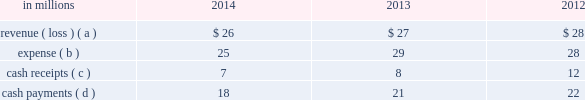The use of the two wholly-owned special purpose entities discussed below preserved the tax deferral that resulted from the 2007 temple-inland timberlands sales .
The company recognized an $ 840 million deferred tax liability in connection with the 2007 sales , which will be settled with the maturity of the notes in in october 2007 , temple-inland sold 1.55 million acres of timberlands for $ 2.38 billion .
The total consideration consisted almost entirely of notes due in 2027 issued by the buyer of the timberlands , which temple-inland contributed to two wholly-owned , bankruptcy-remote special purpose entities .
The notes are shown in financial assets of special purpose entities in the accompanying consolidated balance sheet and are supported by $ 2.38 billion of irrevocable letters of credit issued by three banks , which are required to maintain minimum credit ratings on their long-term debt .
In the third quarter of 2012 , international paper completed its preliminary analysis of the acquisition date fair value of the notes and determined it to be $ 2.09 billion .
As of december 31 , 2014 and 2013 , the fair value of the notes was $ 2.27 billion and $ 2.62 billion , respectively .
These notes are classified as level 2 within the fair value hierarchy , which is further defined in note 14 .
In december 2007 , temple-inland's two wholly-owned special purpose entities borrowed $ 2.14 billion shown in nonrecourse financial liabilities of special purpose entities in the accompanying consolidated balance sheet .
The loans are repayable in 2027 and are secured only by the $ 2.38 billion of notes and the irrevocable letters of credit securing the notes and are nonrecourse to the company .
The loan agreements provide that if a credit rating of any of the banks issuing the letters of credit is downgraded below the specified threshold , the letters of credit issued by that bank must be replaced within 30 days with letters of credit from another qualifying financial institution .
In the third quarter of 2012 , international paper completed its preliminary analysis of the acquisition date fair value of the borrowings and determined it to be $ 2.03 billion .
As of december 31 , 2014 and 2013 , the fair value of this debt was $ 2.16 billion and $ 2.49 billion , respectively .
This debt is classified as level 2 within the fair value hierarchy , which is further defined in note 14 .
During 2012 , the credit ratings for two letter of credit banks that support $ 1.0 billion of the 2007 monetized notes were downgraded below the specified threshold .
These letters of credit were successfully replaced by other qualifying institutions .
Fees of $ 8 million were incurred in connection with these replacements .
Activity between the company and the 2007 financing entities was as follows: .
( a ) the revenue is included in interest expense , net in the accompanying consolidated statement of operations and includes approximately $ 19 million , $ 19 million and $ 17 million for the years ended december 31 , 2014 , 2013 and 2012 , respectively , of accretion income for the amortization of the purchase accounting adjustment of the financial assets of special purpose entities .
( b ) the expense is included in interest expense , net in the accompanying consolidated statement of operations and includes $ 7 million , $ 7 million and $ 6 million for the years ended december 31 , 2014 , 2013 and 2012 , respectively , of accretion expense for the amortization of the purchase accounting adjustment on the nonrecourse financial liabilities of special purpose entities .
( c ) the cash receipts are interest received on the financial assets of special purpose entities .
( d ) the cash payments are interest paid on nonrecourse financial liabilities of special purpose entities .
Preferred securities of subsidiaries in march 2003 , southeast timber , inc .
( southeast timber ) , a consolidated subsidiary of international paper , issued $ 150 million of preferred securities to a private investor with future dividend payments based on libor .
Southeast timber , which through a subsidiary initially held approximately 1.50 million acres of forestlands in the southern united states , was international paper 2019s primary vehicle for sales of southern forestlands .
As of december 31 , 2014 , substantially all of these forestlands have been sold .
On march 27 , 2013 , southeast timber redeemed its class a common shares owned by the private investor for $ 150 million .
Distributions paid to the third-party investor were $ 1 million and $ 6 million in 2013 and 2012 , respectively .
The expense related to these preferred securities is shown in net earnings ( loss ) attributable to noncontrolling interests in the accompanying consolidated statement of operations .
Note 13 debt and lines of credit during the second quarter of 2014 , international paper issued $ 800 million of 3.65% ( 3.65 % ) senior unsecured notes with a maturity date in 2024 and $ 800 million of 4.80% ( 4.80 % ) senior unsecured notes with a maturity date in 2044 .
The proceeds from this borrowing were used to repay approximately $ 960 million of notes with interest rates ranging from 7.95% ( 7.95 % ) to 9.38% ( 9.38 % ) and original maturities from 2018 to 2019 .
Pre-tax early debt retirement costs of $ 262 million related to these debt repayments , including $ 258 million of cash premiums , are included in restructuring and other charges in the .
What was the ratio of the fair value of the preliminary debt analysis of the acquisition date fair value of the borrowings for 2014 to 2013? 
Computations: (2.16 / 2.49)
Answer: 0.86747. 